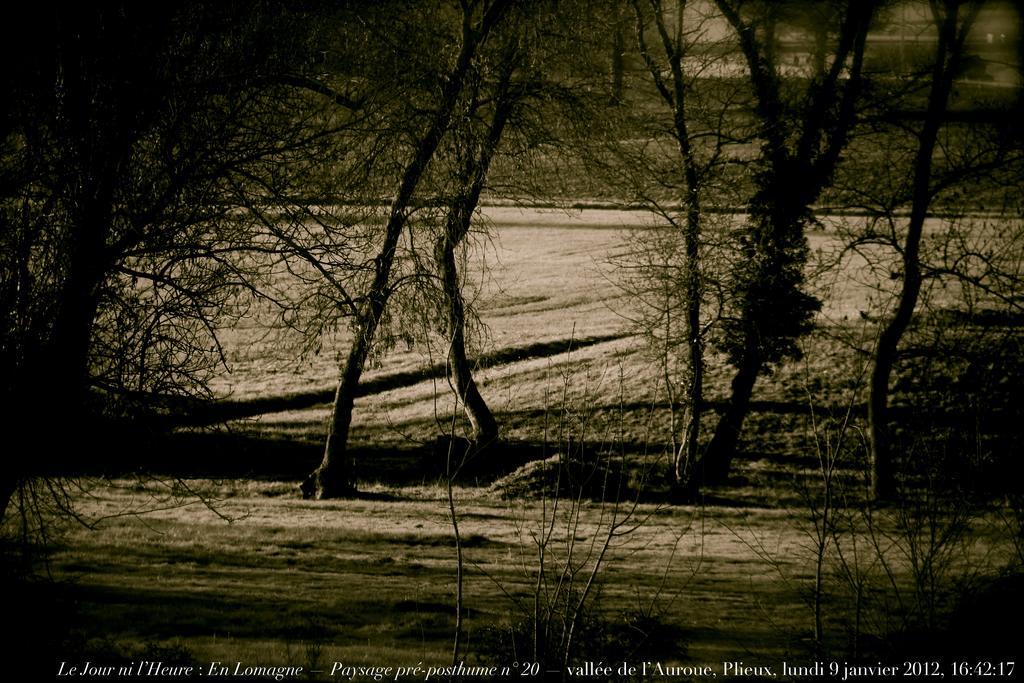In one or two sentences, can you explain what this image depicts? In this picture I can see grass, there are trees, and there is a watermark on the image. 